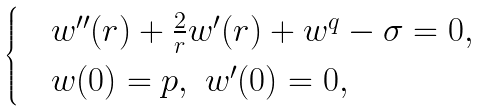<formula> <loc_0><loc_0><loc_500><loc_500>\begin{cases} & w ^ { \prime \prime } ( r ) + \frac { 2 } { r } w ^ { \prime } ( r ) + w ^ { q } - \sigma = 0 , \\ & w ( 0 ) = p , \ w ^ { \prime } ( 0 ) = 0 , \end{cases}</formula> 